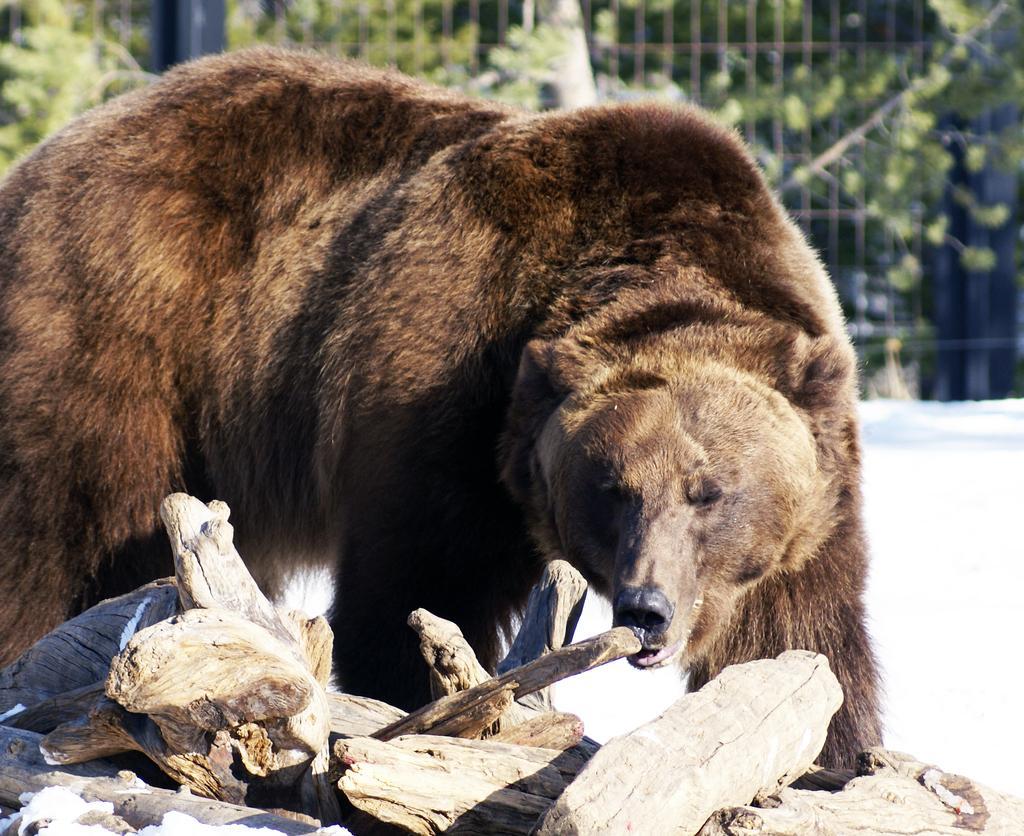Can you describe this image briefly? In this picture, there is a bear which is in brown in color. At the bottom, there are logs. In the background, there is a fence and trees. 